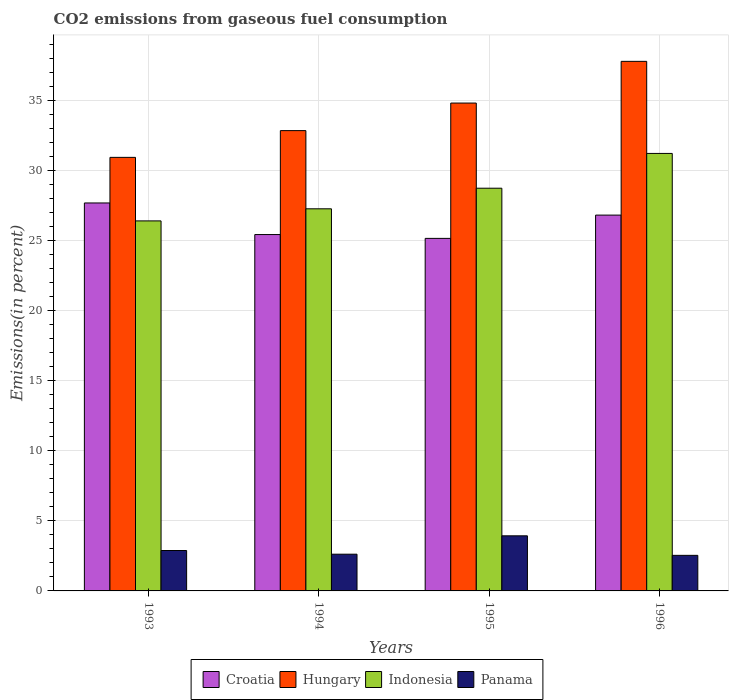How many groups of bars are there?
Provide a short and direct response. 4. Are the number of bars per tick equal to the number of legend labels?
Offer a very short reply. Yes. Are the number of bars on each tick of the X-axis equal?
Your answer should be very brief. Yes. How many bars are there on the 4th tick from the left?
Ensure brevity in your answer.  4. In how many cases, is the number of bars for a given year not equal to the number of legend labels?
Ensure brevity in your answer.  0. What is the total CO2 emitted in Panama in 1995?
Your answer should be very brief. 3.93. Across all years, what is the maximum total CO2 emitted in Indonesia?
Make the answer very short. 31.21. Across all years, what is the minimum total CO2 emitted in Croatia?
Keep it short and to the point. 25.15. In which year was the total CO2 emitted in Croatia maximum?
Offer a very short reply. 1993. What is the total total CO2 emitted in Panama in the graph?
Give a very brief answer. 11.97. What is the difference between the total CO2 emitted in Indonesia in 1993 and that in 1994?
Keep it short and to the point. -0.86. What is the difference between the total CO2 emitted in Hungary in 1994 and the total CO2 emitted in Indonesia in 1995?
Offer a terse response. 4.11. What is the average total CO2 emitted in Hungary per year?
Provide a succinct answer. 34.09. In the year 1996, what is the difference between the total CO2 emitted in Croatia and total CO2 emitted in Hungary?
Your response must be concise. -10.97. What is the ratio of the total CO2 emitted in Panama in 1995 to that in 1996?
Keep it short and to the point. 1.55. Is the total CO2 emitted in Panama in 1995 less than that in 1996?
Give a very brief answer. No. Is the difference between the total CO2 emitted in Croatia in 1994 and 1996 greater than the difference between the total CO2 emitted in Hungary in 1994 and 1996?
Your answer should be very brief. Yes. What is the difference between the highest and the second highest total CO2 emitted in Indonesia?
Offer a very short reply. 2.48. What is the difference between the highest and the lowest total CO2 emitted in Croatia?
Give a very brief answer. 2.53. Is it the case that in every year, the sum of the total CO2 emitted in Indonesia and total CO2 emitted in Panama is greater than the sum of total CO2 emitted in Hungary and total CO2 emitted in Croatia?
Keep it short and to the point. No. What does the 2nd bar from the left in 1993 represents?
Give a very brief answer. Hungary. What does the 2nd bar from the right in 1993 represents?
Keep it short and to the point. Indonesia. How many bars are there?
Your answer should be compact. 16. How many years are there in the graph?
Provide a short and direct response. 4. What is the difference between two consecutive major ticks on the Y-axis?
Give a very brief answer. 5. Where does the legend appear in the graph?
Your answer should be very brief. Bottom center. How are the legend labels stacked?
Offer a terse response. Horizontal. What is the title of the graph?
Ensure brevity in your answer.  CO2 emissions from gaseous fuel consumption. Does "Mauritius" appear as one of the legend labels in the graph?
Your answer should be very brief. No. What is the label or title of the X-axis?
Ensure brevity in your answer.  Years. What is the label or title of the Y-axis?
Ensure brevity in your answer.  Emissions(in percent). What is the Emissions(in percent) in Croatia in 1993?
Offer a very short reply. 27.68. What is the Emissions(in percent) in Hungary in 1993?
Make the answer very short. 30.93. What is the Emissions(in percent) in Indonesia in 1993?
Provide a short and direct response. 26.4. What is the Emissions(in percent) in Panama in 1993?
Make the answer very short. 2.88. What is the Emissions(in percent) of Croatia in 1994?
Keep it short and to the point. 25.42. What is the Emissions(in percent) in Hungary in 1994?
Provide a succinct answer. 32.84. What is the Emissions(in percent) of Indonesia in 1994?
Offer a terse response. 27.26. What is the Emissions(in percent) of Panama in 1994?
Your answer should be very brief. 2.62. What is the Emissions(in percent) in Croatia in 1995?
Give a very brief answer. 25.15. What is the Emissions(in percent) of Hungary in 1995?
Offer a very short reply. 34.81. What is the Emissions(in percent) of Indonesia in 1995?
Provide a short and direct response. 28.73. What is the Emissions(in percent) in Panama in 1995?
Ensure brevity in your answer.  3.93. What is the Emissions(in percent) of Croatia in 1996?
Give a very brief answer. 26.81. What is the Emissions(in percent) of Hungary in 1996?
Keep it short and to the point. 37.78. What is the Emissions(in percent) of Indonesia in 1996?
Provide a succinct answer. 31.21. What is the Emissions(in percent) of Panama in 1996?
Your answer should be very brief. 2.54. Across all years, what is the maximum Emissions(in percent) of Croatia?
Your answer should be compact. 27.68. Across all years, what is the maximum Emissions(in percent) in Hungary?
Your answer should be compact. 37.78. Across all years, what is the maximum Emissions(in percent) of Indonesia?
Offer a very short reply. 31.21. Across all years, what is the maximum Emissions(in percent) in Panama?
Give a very brief answer. 3.93. Across all years, what is the minimum Emissions(in percent) of Croatia?
Provide a short and direct response. 25.15. Across all years, what is the minimum Emissions(in percent) of Hungary?
Ensure brevity in your answer.  30.93. Across all years, what is the minimum Emissions(in percent) in Indonesia?
Your answer should be very brief. 26.4. Across all years, what is the minimum Emissions(in percent) in Panama?
Give a very brief answer. 2.54. What is the total Emissions(in percent) of Croatia in the graph?
Ensure brevity in your answer.  105.07. What is the total Emissions(in percent) in Hungary in the graph?
Offer a terse response. 136.36. What is the total Emissions(in percent) in Indonesia in the graph?
Provide a succinct answer. 113.6. What is the total Emissions(in percent) in Panama in the graph?
Give a very brief answer. 11.97. What is the difference between the Emissions(in percent) in Croatia in 1993 and that in 1994?
Ensure brevity in your answer.  2.25. What is the difference between the Emissions(in percent) in Hungary in 1993 and that in 1994?
Ensure brevity in your answer.  -1.91. What is the difference between the Emissions(in percent) in Indonesia in 1993 and that in 1994?
Give a very brief answer. -0.86. What is the difference between the Emissions(in percent) in Panama in 1993 and that in 1994?
Provide a succinct answer. 0.26. What is the difference between the Emissions(in percent) in Croatia in 1993 and that in 1995?
Your answer should be compact. 2.53. What is the difference between the Emissions(in percent) in Hungary in 1993 and that in 1995?
Keep it short and to the point. -3.87. What is the difference between the Emissions(in percent) of Indonesia in 1993 and that in 1995?
Provide a succinct answer. -2.33. What is the difference between the Emissions(in percent) in Panama in 1993 and that in 1995?
Provide a succinct answer. -1.05. What is the difference between the Emissions(in percent) in Croatia in 1993 and that in 1996?
Give a very brief answer. 0.87. What is the difference between the Emissions(in percent) in Hungary in 1993 and that in 1996?
Keep it short and to the point. -6.85. What is the difference between the Emissions(in percent) in Indonesia in 1993 and that in 1996?
Offer a very short reply. -4.81. What is the difference between the Emissions(in percent) in Panama in 1993 and that in 1996?
Your answer should be compact. 0.35. What is the difference between the Emissions(in percent) of Croatia in 1994 and that in 1995?
Offer a terse response. 0.27. What is the difference between the Emissions(in percent) in Hungary in 1994 and that in 1995?
Your response must be concise. -1.97. What is the difference between the Emissions(in percent) in Indonesia in 1994 and that in 1995?
Offer a very short reply. -1.47. What is the difference between the Emissions(in percent) of Panama in 1994 and that in 1995?
Ensure brevity in your answer.  -1.31. What is the difference between the Emissions(in percent) in Croatia in 1994 and that in 1996?
Offer a very short reply. -1.39. What is the difference between the Emissions(in percent) in Hungary in 1994 and that in 1996?
Provide a succinct answer. -4.94. What is the difference between the Emissions(in percent) of Indonesia in 1994 and that in 1996?
Your answer should be very brief. -3.95. What is the difference between the Emissions(in percent) of Panama in 1994 and that in 1996?
Keep it short and to the point. 0.08. What is the difference between the Emissions(in percent) in Croatia in 1995 and that in 1996?
Ensure brevity in your answer.  -1.66. What is the difference between the Emissions(in percent) of Hungary in 1995 and that in 1996?
Offer a very short reply. -2.98. What is the difference between the Emissions(in percent) of Indonesia in 1995 and that in 1996?
Your answer should be compact. -2.48. What is the difference between the Emissions(in percent) in Panama in 1995 and that in 1996?
Keep it short and to the point. 1.39. What is the difference between the Emissions(in percent) of Croatia in 1993 and the Emissions(in percent) of Hungary in 1994?
Make the answer very short. -5.16. What is the difference between the Emissions(in percent) in Croatia in 1993 and the Emissions(in percent) in Indonesia in 1994?
Your response must be concise. 0.42. What is the difference between the Emissions(in percent) in Croatia in 1993 and the Emissions(in percent) in Panama in 1994?
Provide a short and direct response. 25.06. What is the difference between the Emissions(in percent) in Hungary in 1993 and the Emissions(in percent) in Indonesia in 1994?
Offer a very short reply. 3.67. What is the difference between the Emissions(in percent) of Hungary in 1993 and the Emissions(in percent) of Panama in 1994?
Make the answer very short. 28.31. What is the difference between the Emissions(in percent) in Indonesia in 1993 and the Emissions(in percent) in Panama in 1994?
Ensure brevity in your answer.  23.78. What is the difference between the Emissions(in percent) in Croatia in 1993 and the Emissions(in percent) in Hungary in 1995?
Make the answer very short. -7.13. What is the difference between the Emissions(in percent) of Croatia in 1993 and the Emissions(in percent) of Indonesia in 1995?
Provide a succinct answer. -1.05. What is the difference between the Emissions(in percent) in Croatia in 1993 and the Emissions(in percent) in Panama in 1995?
Keep it short and to the point. 23.75. What is the difference between the Emissions(in percent) of Hungary in 1993 and the Emissions(in percent) of Indonesia in 1995?
Offer a very short reply. 2.2. What is the difference between the Emissions(in percent) in Hungary in 1993 and the Emissions(in percent) in Panama in 1995?
Your answer should be very brief. 27. What is the difference between the Emissions(in percent) in Indonesia in 1993 and the Emissions(in percent) in Panama in 1995?
Make the answer very short. 22.47. What is the difference between the Emissions(in percent) of Croatia in 1993 and the Emissions(in percent) of Hungary in 1996?
Provide a succinct answer. -10.1. What is the difference between the Emissions(in percent) of Croatia in 1993 and the Emissions(in percent) of Indonesia in 1996?
Make the answer very short. -3.53. What is the difference between the Emissions(in percent) of Croatia in 1993 and the Emissions(in percent) of Panama in 1996?
Offer a very short reply. 25.14. What is the difference between the Emissions(in percent) of Hungary in 1993 and the Emissions(in percent) of Indonesia in 1996?
Give a very brief answer. -0.28. What is the difference between the Emissions(in percent) of Hungary in 1993 and the Emissions(in percent) of Panama in 1996?
Your response must be concise. 28.39. What is the difference between the Emissions(in percent) in Indonesia in 1993 and the Emissions(in percent) in Panama in 1996?
Offer a very short reply. 23.86. What is the difference between the Emissions(in percent) of Croatia in 1994 and the Emissions(in percent) of Hungary in 1995?
Ensure brevity in your answer.  -9.38. What is the difference between the Emissions(in percent) of Croatia in 1994 and the Emissions(in percent) of Indonesia in 1995?
Give a very brief answer. -3.31. What is the difference between the Emissions(in percent) of Croatia in 1994 and the Emissions(in percent) of Panama in 1995?
Your answer should be compact. 21.49. What is the difference between the Emissions(in percent) of Hungary in 1994 and the Emissions(in percent) of Indonesia in 1995?
Keep it short and to the point. 4.11. What is the difference between the Emissions(in percent) of Hungary in 1994 and the Emissions(in percent) of Panama in 1995?
Make the answer very short. 28.91. What is the difference between the Emissions(in percent) of Indonesia in 1994 and the Emissions(in percent) of Panama in 1995?
Your answer should be very brief. 23.33. What is the difference between the Emissions(in percent) of Croatia in 1994 and the Emissions(in percent) of Hungary in 1996?
Your response must be concise. -12.36. What is the difference between the Emissions(in percent) in Croatia in 1994 and the Emissions(in percent) in Indonesia in 1996?
Your answer should be compact. -5.79. What is the difference between the Emissions(in percent) in Croatia in 1994 and the Emissions(in percent) in Panama in 1996?
Your response must be concise. 22.89. What is the difference between the Emissions(in percent) of Hungary in 1994 and the Emissions(in percent) of Indonesia in 1996?
Your answer should be compact. 1.63. What is the difference between the Emissions(in percent) in Hungary in 1994 and the Emissions(in percent) in Panama in 1996?
Provide a short and direct response. 30.3. What is the difference between the Emissions(in percent) in Indonesia in 1994 and the Emissions(in percent) in Panama in 1996?
Ensure brevity in your answer.  24.72. What is the difference between the Emissions(in percent) in Croatia in 1995 and the Emissions(in percent) in Hungary in 1996?
Make the answer very short. -12.63. What is the difference between the Emissions(in percent) of Croatia in 1995 and the Emissions(in percent) of Indonesia in 1996?
Your answer should be very brief. -6.06. What is the difference between the Emissions(in percent) in Croatia in 1995 and the Emissions(in percent) in Panama in 1996?
Make the answer very short. 22.61. What is the difference between the Emissions(in percent) of Hungary in 1995 and the Emissions(in percent) of Indonesia in 1996?
Your response must be concise. 3.59. What is the difference between the Emissions(in percent) in Hungary in 1995 and the Emissions(in percent) in Panama in 1996?
Your response must be concise. 32.27. What is the difference between the Emissions(in percent) in Indonesia in 1995 and the Emissions(in percent) in Panama in 1996?
Offer a terse response. 26.19. What is the average Emissions(in percent) in Croatia per year?
Offer a very short reply. 26.27. What is the average Emissions(in percent) of Hungary per year?
Make the answer very short. 34.09. What is the average Emissions(in percent) in Indonesia per year?
Your answer should be very brief. 28.4. What is the average Emissions(in percent) in Panama per year?
Make the answer very short. 2.99. In the year 1993, what is the difference between the Emissions(in percent) of Croatia and Emissions(in percent) of Hungary?
Offer a terse response. -3.25. In the year 1993, what is the difference between the Emissions(in percent) in Croatia and Emissions(in percent) in Indonesia?
Make the answer very short. 1.28. In the year 1993, what is the difference between the Emissions(in percent) of Croatia and Emissions(in percent) of Panama?
Give a very brief answer. 24.79. In the year 1993, what is the difference between the Emissions(in percent) of Hungary and Emissions(in percent) of Indonesia?
Your response must be concise. 4.53. In the year 1993, what is the difference between the Emissions(in percent) of Hungary and Emissions(in percent) of Panama?
Your answer should be compact. 28.05. In the year 1993, what is the difference between the Emissions(in percent) in Indonesia and Emissions(in percent) in Panama?
Give a very brief answer. 23.51. In the year 1994, what is the difference between the Emissions(in percent) of Croatia and Emissions(in percent) of Hungary?
Give a very brief answer. -7.42. In the year 1994, what is the difference between the Emissions(in percent) in Croatia and Emissions(in percent) in Indonesia?
Keep it short and to the point. -1.84. In the year 1994, what is the difference between the Emissions(in percent) in Croatia and Emissions(in percent) in Panama?
Offer a terse response. 22.8. In the year 1994, what is the difference between the Emissions(in percent) of Hungary and Emissions(in percent) of Indonesia?
Your answer should be very brief. 5.58. In the year 1994, what is the difference between the Emissions(in percent) of Hungary and Emissions(in percent) of Panama?
Give a very brief answer. 30.22. In the year 1994, what is the difference between the Emissions(in percent) in Indonesia and Emissions(in percent) in Panama?
Ensure brevity in your answer.  24.64. In the year 1995, what is the difference between the Emissions(in percent) in Croatia and Emissions(in percent) in Hungary?
Provide a short and direct response. -9.65. In the year 1995, what is the difference between the Emissions(in percent) of Croatia and Emissions(in percent) of Indonesia?
Ensure brevity in your answer.  -3.58. In the year 1995, what is the difference between the Emissions(in percent) of Croatia and Emissions(in percent) of Panama?
Provide a short and direct response. 21.22. In the year 1995, what is the difference between the Emissions(in percent) of Hungary and Emissions(in percent) of Indonesia?
Your answer should be very brief. 6.07. In the year 1995, what is the difference between the Emissions(in percent) of Hungary and Emissions(in percent) of Panama?
Your response must be concise. 30.87. In the year 1995, what is the difference between the Emissions(in percent) in Indonesia and Emissions(in percent) in Panama?
Your answer should be very brief. 24.8. In the year 1996, what is the difference between the Emissions(in percent) in Croatia and Emissions(in percent) in Hungary?
Make the answer very short. -10.97. In the year 1996, what is the difference between the Emissions(in percent) in Croatia and Emissions(in percent) in Indonesia?
Offer a very short reply. -4.4. In the year 1996, what is the difference between the Emissions(in percent) in Croatia and Emissions(in percent) in Panama?
Provide a succinct answer. 24.27. In the year 1996, what is the difference between the Emissions(in percent) of Hungary and Emissions(in percent) of Indonesia?
Your answer should be very brief. 6.57. In the year 1996, what is the difference between the Emissions(in percent) of Hungary and Emissions(in percent) of Panama?
Give a very brief answer. 35.24. In the year 1996, what is the difference between the Emissions(in percent) in Indonesia and Emissions(in percent) in Panama?
Offer a terse response. 28.67. What is the ratio of the Emissions(in percent) of Croatia in 1993 to that in 1994?
Ensure brevity in your answer.  1.09. What is the ratio of the Emissions(in percent) in Hungary in 1993 to that in 1994?
Provide a short and direct response. 0.94. What is the ratio of the Emissions(in percent) of Indonesia in 1993 to that in 1994?
Offer a very short reply. 0.97. What is the ratio of the Emissions(in percent) in Panama in 1993 to that in 1994?
Ensure brevity in your answer.  1.1. What is the ratio of the Emissions(in percent) in Croatia in 1993 to that in 1995?
Ensure brevity in your answer.  1.1. What is the ratio of the Emissions(in percent) in Hungary in 1993 to that in 1995?
Provide a succinct answer. 0.89. What is the ratio of the Emissions(in percent) in Indonesia in 1993 to that in 1995?
Provide a short and direct response. 0.92. What is the ratio of the Emissions(in percent) of Panama in 1993 to that in 1995?
Make the answer very short. 0.73. What is the ratio of the Emissions(in percent) in Croatia in 1993 to that in 1996?
Your answer should be compact. 1.03. What is the ratio of the Emissions(in percent) of Hungary in 1993 to that in 1996?
Keep it short and to the point. 0.82. What is the ratio of the Emissions(in percent) of Indonesia in 1993 to that in 1996?
Ensure brevity in your answer.  0.85. What is the ratio of the Emissions(in percent) in Panama in 1993 to that in 1996?
Your answer should be compact. 1.14. What is the ratio of the Emissions(in percent) in Croatia in 1994 to that in 1995?
Keep it short and to the point. 1.01. What is the ratio of the Emissions(in percent) of Hungary in 1994 to that in 1995?
Keep it short and to the point. 0.94. What is the ratio of the Emissions(in percent) in Indonesia in 1994 to that in 1995?
Your response must be concise. 0.95. What is the ratio of the Emissions(in percent) in Panama in 1994 to that in 1995?
Keep it short and to the point. 0.67. What is the ratio of the Emissions(in percent) of Croatia in 1994 to that in 1996?
Give a very brief answer. 0.95. What is the ratio of the Emissions(in percent) of Hungary in 1994 to that in 1996?
Provide a succinct answer. 0.87. What is the ratio of the Emissions(in percent) in Indonesia in 1994 to that in 1996?
Offer a very short reply. 0.87. What is the ratio of the Emissions(in percent) of Panama in 1994 to that in 1996?
Your answer should be compact. 1.03. What is the ratio of the Emissions(in percent) in Croatia in 1995 to that in 1996?
Offer a terse response. 0.94. What is the ratio of the Emissions(in percent) in Hungary in 1995 to that in 1996?
Offer a very short reply. 0.92. What is the ratio of the Emissions(in percent) of Indonesia in 1995 to that in 1996?
Offer a terse response. 0.92. What is the ratio of the Emissions(in percent) in Panama in 1995 to that in 1996?
Offer a terse response. 1.55. What is the difference between the highest and the second highest Emissions(in percent) of Croatia?
Make the answer very short. 0.87. What is the difference between the highest and the second highest Emissions(in percent) of Hungary?
Your answer should be compact. 2.98. What is the difference between the highest and the second highest Emissions(in percent) of Indonesia?
Make the answer very short. 2.48. What is the difference between the highest and the second highest Emissions(in percent) in Panama?
Keep it short and to the point. 1.05. What is the difference between the highest and the lowest Emissions(in percent) in Croatia?
Keep it short and to the point. 2.53. What is the difference between the highest and the lowest Emissions(in percent) in Hungary?
Your response must be concise. 6.85. What is the difference between the highest and the lowest Emissions(in percent) of Indonesia?
Make the answer very short. 4.81. What is the difference between the highest and the lowest Emissions(in percent) in Panama?
Offer a very short reply. 1.39. 